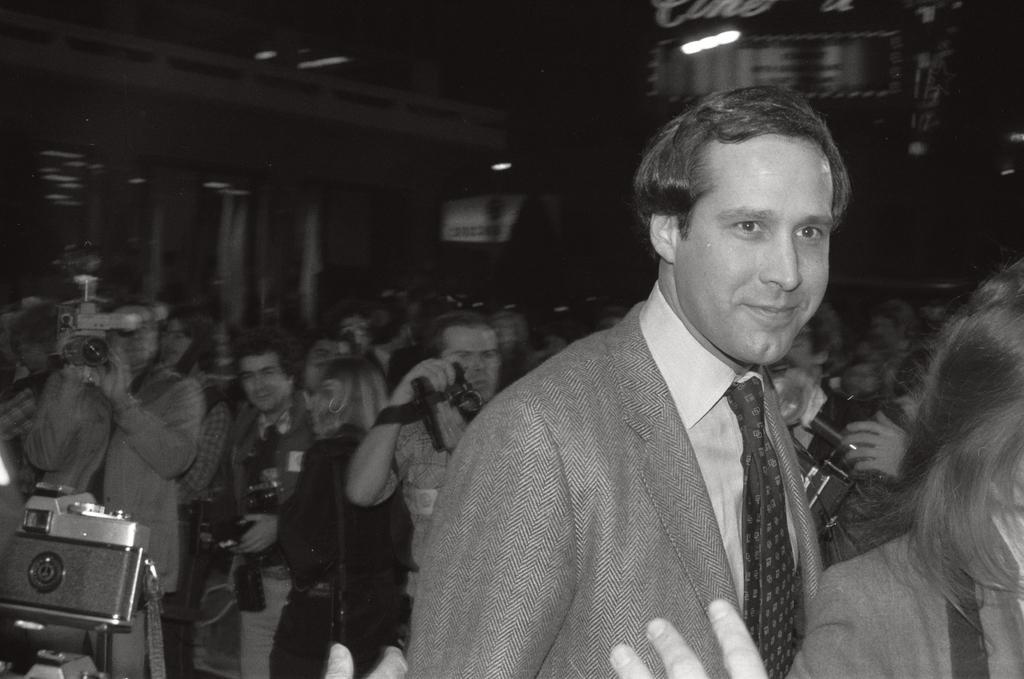Could you give a brief overview of what you see in this image? As we can see in the image, there are group of people standing and few of them are holding cameras in their hands. 